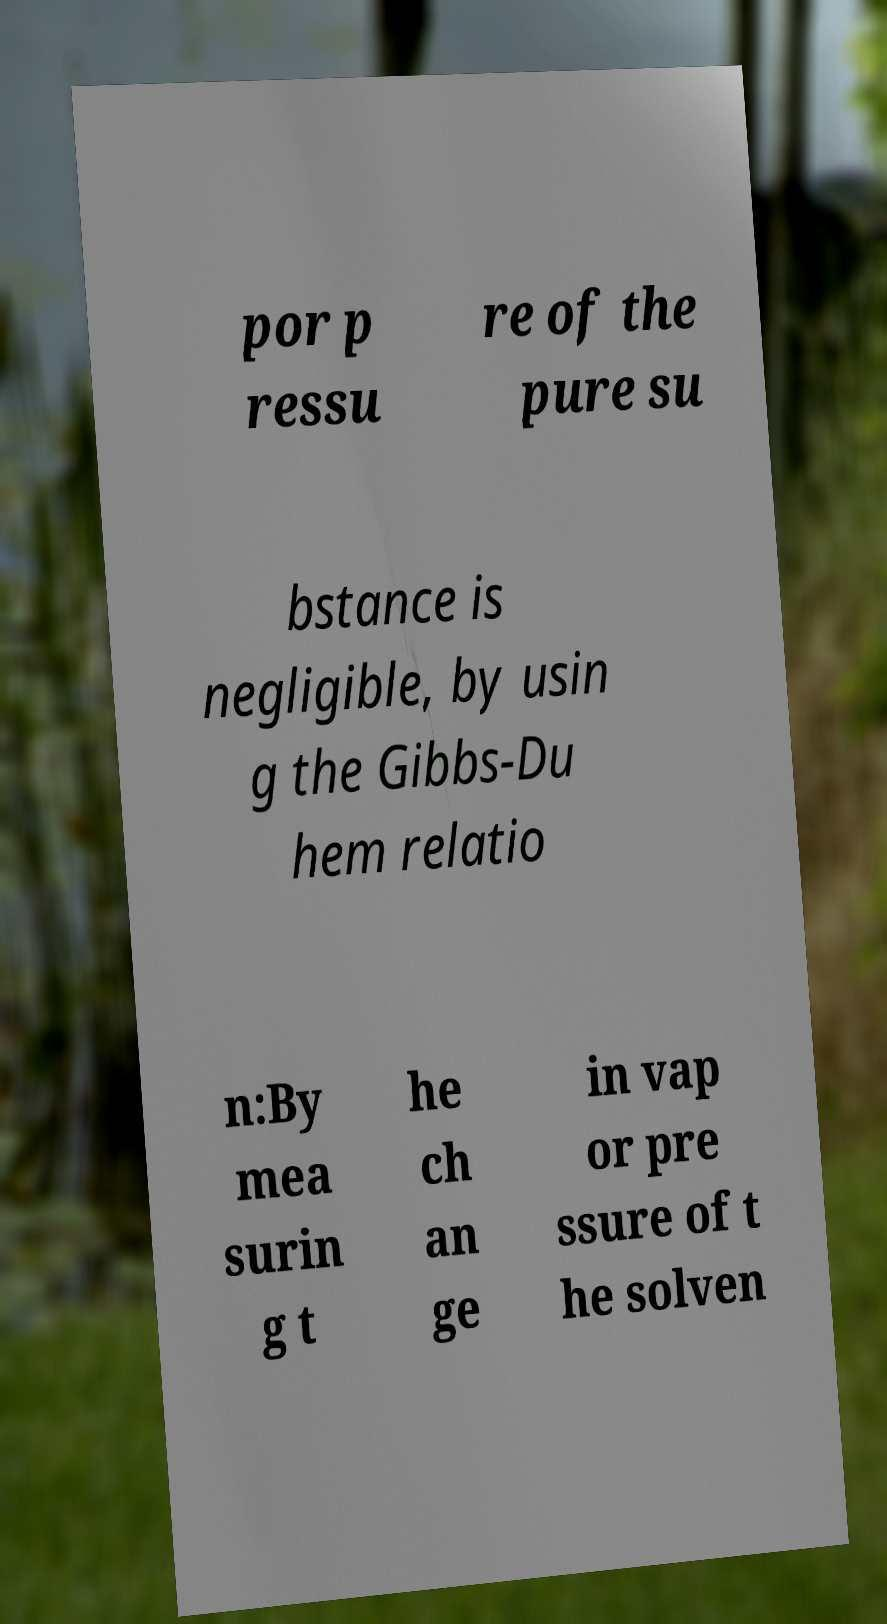Can you accurately transcribe the text from the provided image for me? por p ressu re of the pure su bstance is negligible, by usin g the Gibbs-Du hem relatio n:By mea surin g t he ch an ge in vap or pre ssure of t he solven 